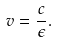Convert formula to latex. <formula><loc_0><loc_0><loc_500><loc_500>v = \frac { c } { \epsilon } .</formula> 